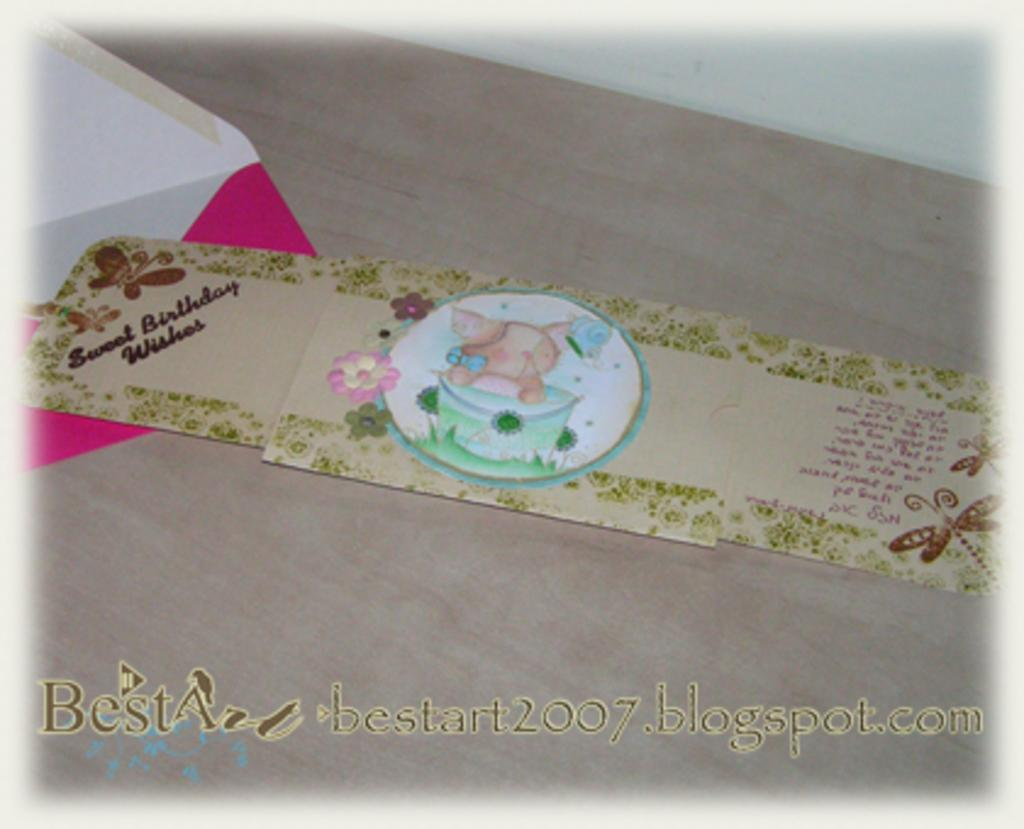<image>
Describe the image concisely. A birthday card with a pig in a bucket on it 